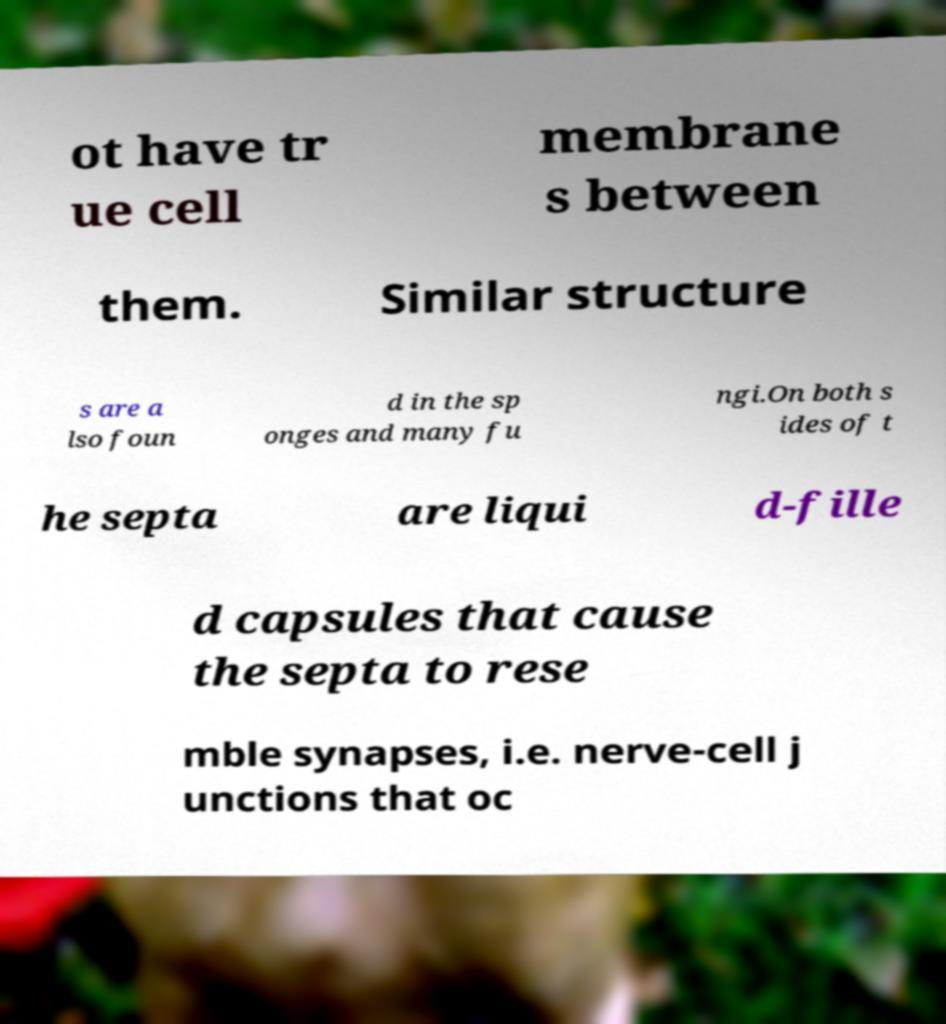For documentation purposes, I need the text within this image transcribed. Could you provide that? ot have tr ue cell membrane s between them. Similar structure s are a lso foun d in the sp onges and many fu ngi.On both s ides of t he septa are liqui d-fille d capsules that cause the septa to rese mble synapses, i.e. nerve-cell j unctions that oc 